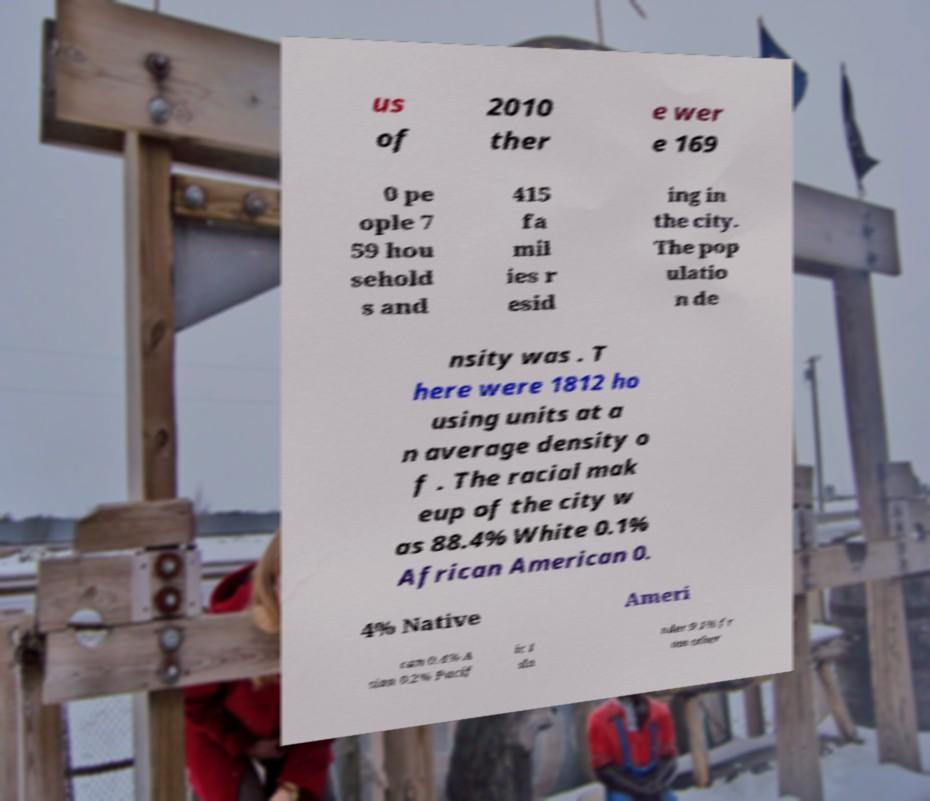There's text embedded in this image that I need extracted. Can you transcribe it verbatim? us of 2010 ther e wer e 169 0 pe ople 7 59 hou sehold s and 415 fa mil ies r esid ing in the city. The pop ulatio n de nsity was . T here were 1812 ho using units at a n average density o f . The racial mak eup of the city w as 88.4% White 0.1% African American 0. 4% Native Ameri can 0.4% A sian 0.2% Pacif ic I sla nder 9.1% fr om other 